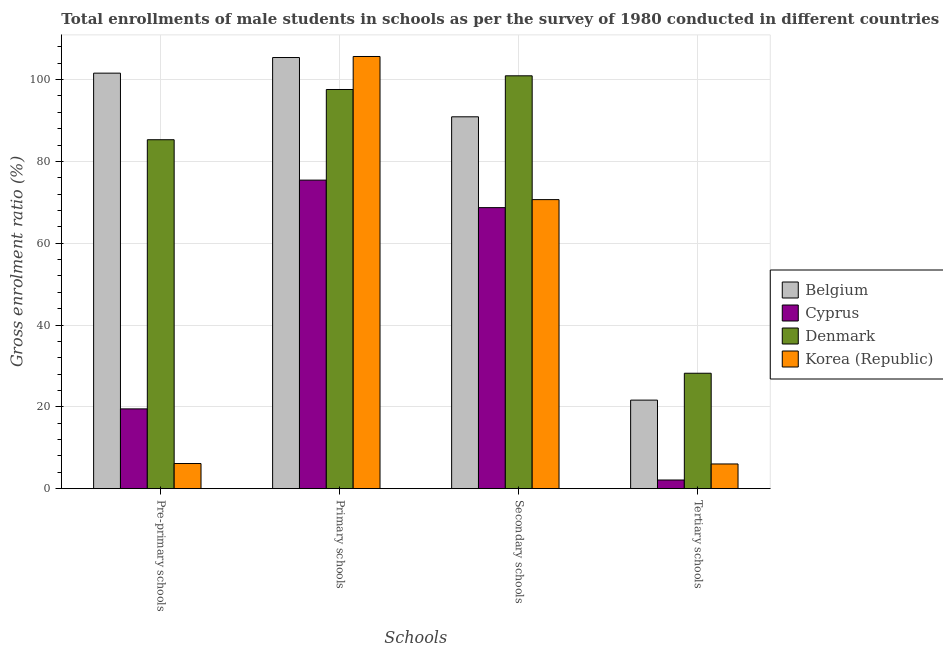Are the number of bars per tick equal to the number of legend labels?
Provide a short and direct response. Yes. How many bars are there on the 2nd tick from the left?
Ensure brevity in your answer.  4. What is the label of the 4th group of bars from the left?
Ensure brevity in your answer.  Tertiary schools. What is the gross enrolment ratio(male) in primary schools in Denmark?
Provide a short and direct response. 97.58. Across all countries, what is the maximum gross enrolment ratio(male) in tertiary schools?
Give a very brief answer. 28.22. Across all countries, what is the minimum gross enrolment ratio(male) in pre-primary schools?
Your response must be concise. 6.15. In which country was the gross enrolment ratio(male) in tertiary schools maximum?
Your response must be concise. Denmark. In which country was the gross enrolment ratio(male) in tertiary schools minimum?
Offer a terse response. Cyprus. What is the total gross enrolment ratio(male) in pre-primary schools in the graph?
Make the answer very short. 212.52. What is the difference between the gross enrolment ratio(male) in pre-primary schools in Cyprus and that in Belgium?
Give a very brief answer. -82.07. What is the difference between the gross enrolment ratio(male) in pre-primary schools in Korea (Republic) and the gross enrolment ratio(male) in secondary schools in Cyprus?
Provide a succinct answer. -62.55. What is the average gross enrolment ratio(male) in tertiary schools per country?
Offer a terse response. 14.51. What is the difference between the gross enrolment ratio(male) in secondary schools and gross enrolment ratio(male) in pre-primary schools in Belgium?
Ensure brevity in your answer.  -10.67. In how many countries, is the gross enrolment ratio(male) in secondary schools greater than 68 %?
Make the answer very short. 4. What is the ratio of the gross enrolment ratio(male) in pre-primary schools in Cyprus to that in Korea (Republic)?
Make the answer very short. 3.17. What is the difference between the highest and the second highest gross enrolment ratio(male) in primary schools?
Keep it short and to the point. 0.25. What is the difference between the highest and the lowest gross enrolment ratio(male) in secondary schools?
Your response must be concise. 32.22. In how many countries, is the gross enrolment ratio(male) in tertiary schools greater than the average gross enrolment ratio(male) in tertiary schools taken over all countries?
Your response must be concise. 2. Is the sum of the gross enrolment ratio(male) in secondary schools in Korea (Republic) and Cyprus greater than the maximum gross enrolment ratio(male) in pre-primary schools across all countries?
Ensure brevity in your answer.  Yes. What does the 3rd bar from the left in Primary schools represents?
Provide a succinct answer. Denmark. What does the 2nd bar from the right in Tertiary schools represents?
Ensure brevity in your answer.  Denmark. Is it the case that in every country, the sum of the gross enrolment ratio(male) in pre-primary schools and gross enrolment ratio(male) in primary schools is greater than the gross enrolment ratio(male) in secondary schools?
Provide a succinct answer. Yes. How many bars are there?
Provide a short and direct response. 16. Are all the bars in the graph horizontal?
Provide a succinct answer. No. How many countries are there in the graph?
Offer a very short reply. 4. What is the difference between two consecutive major ticks on the Y-axis?
Provide a succinct answer. 20. Are the values on the major ticks of Y-axis written in scientific E-notation?
Your response must be concise. No. How many legend labels are there?
Your answer should be compact. 4. How are the legend labels stacked?
Offer a terse response. Vertical. What is the title of the graph?
Give a very brief answer. Total enrollments of male students in schools as per the survey of 1980 conducted in different countries. Does "Senegal" appear as one of the legend labels in the graph?
Your answer should be very brief. No. What is the label or title of the X-axis?
Your response must be concise. Schools. What is the label or title of the Y-axis?
Your answer should be compact. Gross enrolment ratio (%). What is the Gross enrolment ratio (%) of Belgium in Pre-primary schools?
Your response must be concise. 101.57. What is the Gross enrolment ratio (%) of Cyprus in Pre-primary schools?
Give a very brief answer. 19.5. What is the Gross enrolment ratio (%) of Denmark in Pre-primary schools?
Your response must be concise. 85.29. What is the Gross enrolment ratio (%) in Korea (Republic) in Pre-primary schools?
Your answer should be compact. 6.15. What is the Gross enrolment ratio (%) of Belgium in Primary schools?
Your answer should be compact. 105.39. What is the Gross enrolment ratio (%) in Cyprus in Primary schools?
Provide a succinct answer. 75.42. What is the Gross enrolment ratio (%) in Denmark in Primary schools?
Your answer should be compact. 97.58. What is the Gross enrolment ratio (%) of Korea (Republic) in Primary schools?
Offer a very short reply. 105.64. What is the Gross enrolment ratio (%) in Belgium in Secondary schools?
Ensure brevity in your answer.  90.9. What is the Gross enrolment ratio (%) of Cyprus in Secondary schools?
Offer a terse response. 68.7. What is the Gross enrolment ratio (%) of Denmark in Secondary schools?
Ensure brevity in your answer.  100.92. What is the Gross enrolment ratio (%) of Korea (Republic) in Secondary schools?
Keep it short and to the point. 70.66. What is the Gross enrolment ratio (%) in Belgium in Tertiary schools?
Make the answer very short. 21.65. What is the Gross enrolment ratio (%) in Cyprus in Tertiary schools?
Offer a very short reply. 2.12. What is the Gross enrolment ratio (%) of Denmark in Tertiary schools?
Keep it short and to the point. 28.22. What is the Gross enrolment ratio (%) in Korea (Republic) in Tertiary schools?
Provide a succinct answer. 6.04. Across all Schools, what is the maximum Gross enrolment ratio (%) in Belgium?
Keep it short and to the point. 105.39. Across all Schools, what is the maximum Gross enrolment ratio (%) in Cyprus?
Give a very brief answer. 75.42. Across all Schools, what is the maximum Gross enrolment ratio (%) in Denmark?
Provide a succinct answer. 100.92. Across all Schools, what is the maximum Gross enrolment ratio (%) in Korea (Republic)?
Give a very brief answer. 105.64. Across all Schools, what is the minimum Gross enrolment ratio (%) of Belgium?
Ensure brevity in your answer.  21.65. Across all Schools, what is the minimum Gross enrolment ratio (%) of Cyprus?
Ensure brevity in your answer.  2.12. Across all Schools, what is the minimum Gross enrolment ratio (%) in Denmark?
Your answer should be very brief. 28.22. Across all Schools, what is the minimum Gross enrolment ratio (%) of Korea (Republic)?
Keep it short and to the point. 6.04. What is the total Gross enrolment ratio (%) of Belgium in the graph?
Offer a terse response. 319.5. What is the total Gross enrolment ratio (%) of Cyprus in the graph?
Ensure brevity in your answer.  165.74. What is the total Gross enrolment ratio (%) of Denmark in the graph?
Provide a succinct answer. 312. What is the total Gross enrolment ratio (%) in Korea (Republic) in the graph?
Make the answer very short. 188.49. What is the difference between the Gross enrolment ratio (%) of Belgium in Pre-primary schools and that in Primary schools?
Provide a short and direct response. -3.82. What is the difference between the Gross enrolment ratio (%) of Cyprus in Pre-primary schools and that in Primary schools?
Your response must be concise. -55.92. What is the difference between the Gross enrolment ratio (%) in Denmark in Pre-primary schools and that in Primary schools?
Ensure brevity in your answer.  -12.28. What is the difference between the Gross enrolment ratio (%) in Korea (Republic) in Pre-primary schools and that in Primary schools?
Provide a succinct answer. -99.49. What is the difference between the Gross enrolment ratio (%) in Belgium in Pre-primary schools and that in Secondary schools?
Offer a terse response. 10.67. What is the difference between the Gross enrolment ratio (%) of Cyprus in Pre-primary schools and that in Secondary schools?
Your answer should be compact. -49.2. What is the difference between the Gross enrolment ratio (%) in Denmark in Pre-primary schools and that in Secondary schools?
Your response must be concise. -15.62. What is the difference between the Gross enrolment ratio (%) in Korea (Republic) in Pre-primary schools and that in Secondary schools?
Provide a succinct answer. -64.51. What is the difference between the Gross enrolment ratio (%) in Belgium in Pre-primary schools and that in Tertiary schools?
Keep it short and to the point. 79.92. What is the difference between the Gross enrolment ratio (%) in Cyprus in Pre-primary schools and that in Tertiary schools?
Ensure brevity in your answer.  17.38. What is the difference between the Gross enrolment ratio (%) of Denmark in Pre-primary schools and that in Tertiary schools?
Ensure brevity in your answer.  57.08. What is the difference between the Gross enrolment ratio (%) in Korea (Republic) in Pre-primary schools and that in Tertiary schools?
Your answer should be very brief. 0.11. What is the difference between the Gross enrolment ratio (%) of Belgium in Primary schools and that in Secondary schools?
Provide a succinct answer. 14.49. What is the difference between the Gross enrolment ratio (%) of Cyprus in Primary schools and that in Secondary schools?
Give a very brief answer. 6.72. What is the difference between the Gross enrolment ratio (%) of Denmark in Primary schools and that in Secondary schools?
Provide a short and direct response. -3.34. What is the difference between the Gross enrolment ratio (%) in Korea (Republic) in Primary schools and that in Secondary schools?
Provide a succinct answer. 34.99. What is the difference between the Gross enrolment ratio (%) in Belgium in Primary schools and that in Tertiary schools?
Your answer should be very brief. 83.74. What is the difference between the Gross enrolment ratio (%) in Cyprus in Primary schools and that in Tertiary schools?
Ensure brevity in your answer.  73.3. What is the difference between the Gross enrolment ratio (%) in Denmark in Primary schools and that in Tertiary schools?
Provide a succinct answer. 69.36. What is the difference between the Gross enrolment ratio (%) of Korea (Republic) in Primary schools and that in Tertiary schools?
Offer a very short reply. 99.6. What is the difference between the Gross enrolment ratio (%) in Belgium in Secondary schools and that in Tertiary schools?
Keep it short and to the point. 69.25. What is the difference between the Gross enrolment ratio (%) in Cyprus in Secondary schools and that in Tertiary schools?
Keep it short and to the point. 66.58. What is the difference between the Gross enrolment ratio (%) of Denmark in Secondary schools and that in Tertiary schools?
Offer a terse response. 72.7. What is the difference between the Gross enrolment ratio (%) in Korea (Republic) in Secondary schools and that in Tertiary schools?
Your answer should be very brief. 64.62. What is the difference between the Gross enrolment ratio (%) in Belgium in Pre-primary schools and the Gross enrolment ratio (%) in Cyprus in Primary schools?
Your response must be concise. 26.15. What is the difference between the Gross enrolment ratio (%) in Belgium in Pre-primary schools and the Gross enrolment ratio (%) in Denmark in Primary schools?
Ensure brevity in your answer.  3.99. What is the difference between the Gross enrolment ratio (%) in Belgium in Pre-primary schools and the Gross enrolment ratio (%) in Korea (Republic) in Primary schools?
Keep it short and to the point. -4.07. What is the difference between the Gross enrolment ratio (%) of Cyprus in Pre-primary schools and the Gross enrolment ratio (%) of Denmark in Primary schools?
Offer a terse response. -78.07. What is the difference between the Gross enrolment ratio (%) in Cyprus in Pre-primary schools and the Gross enrolment ratio (%) in Korea (Republic) in Primary schools?
Offer a very short reply. -86.14. What is the difference between the Gross enrolment ratio (%) in Denmark in Pre-primary schools and the Gross enrolment ratio (%) in Korea (Republic) in Primary schools?
Your answer should be compact. -20.35. What is the difference between the Gross enrolment ratio (%) in Belgium in Pre-primary schools and the Gross enrolment ratio (%) in Cyprus in Secondary schools?
Give a very brief answer. 32.87. What is the difference between the Gross enrolment ratio (%) of Belgium in Pre-primary schools and the Gross enrolment ratio (%) of Denmark in Secondary schools?
Your answer should be very brief. 0.65. What is the difference between the Gross enrolment ratio (%) of Belgium in Pre-primary schools and the Gross enrolment ratio (%) of Korea (Republic) in Secondary schools?
Your answer should be compact. 30.91. What is the difference between the Gross enrolment ratio (%) of Cyprus in Pre-primary schools and the Gross enrolment ratio (%) of Denmark in Secondary schools?
Keep it short and to the point. -81.42. What is the difference between the Gross enrolment ratio (%) of Cyprus in Pre-primary schools and the Gross enrolment ratio (%) of Korea (Republic) in Secondary schools?
Make the answer very short. -51.15. What is the difference between the Gross enrolment ratio (%) of Denmark in Pre-primary schools and the Gross enrolment ratio (%) of Korea (Republic) in Secondary schools?
Provide a short and direct response. 14.64. What is the difference between the Gross enrolment ratio (%) in Belgium in Pre-primary schools and the Gross enrolment ratio (%) in Cyprus in Tertiary schools?
Your answer should be very brief. 99.45. What is the difference between the Gross enrolment ratio (%) in Belgium in Pre-primary schools and the Gross enrolment ratio (%) in Denmark in Tertiary schools?
Provide a succinct answer. 73.35. What is the difference between the Gross enrolment ratio (%) in Belgium in Pre-primary schools and the Gross enrolment ratio (%) in Korea (Republic) in Tertiary schools?
Give a very brief answer. 95.53. What is the difference between the Gross enrolment ratio (%) in Cyprus in Pre-primary schools and the Gross enrolment ratio (%) in Denmark in Tertiary schools?
Offer a very short reply. -8.71. What is the difference between the Gross enrolment ratio (%) in Cyprus in Pre-primary schools and the Gross enrolment ratio (%) in Korea (Republic) in Tertiary schools?
Provide a short and direct response. 13.46. What is the difference between the Gross enrolment ratio (%) of Denmark in Pre-primary schools and the Gross enrolment ratio (%) of Korea (Republic) in Tertiary schools?
Your answer should be very brief. 79.25. What is the difference between the Gross enrolment ratio (%) in Belgium in Primary schools and the Gross enrolment ratio (%) in Cyprus in Secondary schools?
Give a very brief answer. 36.69. What is the difference between the Gross enrolment ratio (%) of Belgium in Primary schools and the Gross enrolment ratio (%) of Denmark in Secondary schools?
Your response must be concise. 4.47. What is the difference between the Gross enrolment ratio (%) in Belgium in Primary schools and the Gross enrolment ratio (%) in Korea (Republic) in Secondary schools?
Make the answer very short. 34.73. What is the difference between the Gross enrolment ratio (%) of Cyprus in Primary schools and the Gross enrolment ratio (%) of Denmark in Secondary schools?
Make the answer very short. -25.5. What is the difference between the Gross enrolment ratio (%) of Cyprus in Primary schools and the Gross enrolment ratio (%) of Korea (Republic) in Secondary schools?
Make the answer very short. 4.76. What is the difference between the Gross enrolment ratio (%) of Denmark in Primary schools and the Gross enrolment ratio (%) of Korea (Republic) in Secondary schools?
Provide a short and direct response. 26.92. What is the difference between the Gross enrolment ratio (%) of Belgium in Primary schools and the Gross enrolment ratio (%) of Cyprus in Tertiary schools?
Your answer should be compact. 103.27. What is the difference between the Gross enrolment ratio (%) in Belgium in Primary schools and the Gross enrolment ratio (%) in Denmark in Tertiary schools?
Give a very brief answer. 77.18. What is the difference between the Gross enrolment ratio (%) of Belgium in Primary schools and the Gross enrolment ratio (%) of Korea (Republic) in Tertiary schools?
Your answer should be compact. 99.35. What is the difference between the Gross enrolment ratio (%) in Cyprus in Primary schools and the Gross enrolment ratio (%) in Denmark in Tertiary schools?
Provide a succinct answer. 47.21. What is the difference between the Gross enrolment ratio (%) in Cyprus in Primary schools and the Gross enrolment ratio (%) in Korea (Republic) in Tertiary schools?
Your answer should be compact. 69.38. What is the difference between the Gross enrolment ratio (%) in Denmark in Primary schools and the Gross enrolment ratio (%) in Korea (Republic) in Tertiary schools?
Make the answer very short. 91.53. What is the difference between the Gross enrolment ratio (%) in Belgium in Secondary schools and the Gross enrolment ratio (%) in Cyprus in Tertiary schools?
Provide a short and direct response. 88.78. What is the difference between the Gross enrolment ratio (%) of Belgium in Secondary schools and the Gross enrolment ratio (%) of Denmark in Tertiary schools?
Offer a terse response. 62.68. What is the difference between the Gross enrolment ratio (%) in Belgium in Secondary schools and the Gross enrolment ratio (%) in Korea (Republic) in Tertiary schools?
Provide a succinct answer. 84.86. What is the difference between the Gross enrolment ratio (%) of Cyprus in Secondary schools and the Gross enrolment ratio (%) of Denmark in Tertiary schools?
Make the answer very short. 40.48. What is the difference between the Gross enrolment ratio (%) of Cyprus in Secondary schools and the Gross enrolment ratio (%) of Korea (Republic) in Tertiary schools?
Ensure brevity in your answer.  62.66. What is the difference between the Gross enrolment ratio (%) of Denmark in Secondary schools and the Gross enrolment ratio (%) of Korea (Republic) in Tertiary schools?
Offer a terse response. 94.88. What is the average Gross enrolment ratio (%) in Belgium per Schools?
Your response must be concise. 79.88. What is the average Gross enrolment ratio (%) of Cyprus per Schools?
Give a very brief answer. 41.44. What is the average Gross enrolment ratio (%) in Denmark per Schools?
Keep it short and to the point. 78. What is the average Gross enrolment ratio (%) in Korea (Republic) per Schools?
Give a very brief answer. 47.12. What is the difference between the Gross enrolment ratio (%) of Belgium and Gross enrolment ratio (%) of Cyprus in Pre-primary schools?
Your answer should be compact. 82.07. What is the difference between the Gross enrolment ratio (%) of Belgium and Gross enrolment ratio (%) of Denmark in Pre-primary schools?
Provide a succinct answer. 16.27. What is the difference between the Gross enrolment ratio (%) in Belgium and Gross enrolment ratio (%) in Korea (Republic) in Pre-primary schools?
Make the answer very short. 95.42. What is the difference between the Gross enrolment ratio (%) in Cyprus and Gross enrolment ratio (%) in Denmark in Pre-primary schools?
Your answer should be very brief. -65.79. What is the difference between the Gross enrolment ratio (%) of Cyprus and Gross enrolment ratio (%) of Korea (Republic) in Pre-primary schools?
Provide a short and direct response. 13.36. What is the difference between the Gross enrolment ratio (%) in Denmark and Gross enrolment ratio (%) in Korea (Republic) in Pre-primary schools?
Ensure brevity in your answer.  79.15. What is the difference between the Gross enrolment ratio (%) in Belgium and Gross enrolment ratio (%) in Cyprus in Primary schools?
Offer a terse response. 29.97. What is the difference between the Gross enrolment ratio (%) in Belgium and Gross enrolment ratio (%) in Denmark in Primary schools?
Provide a short and direct response. 7.81. What is the difference between the Gross enrolment ratio (%) of Belgium and Gross enrolment ratio (%) of Korea (Republic) in Primary schools?
Make the answer very short. -0.25. What is the difference between the Gross enrolment ratio (%) in Cyprus and Gross enrolment ratio (%) in Denmark in Primary schools?
Provide a short and direct response. -22.15. What is the difference between the Gross enrolment ratio (%) of Cyprus and Gross enrolment ratio (%) of Korea (Republic) in Primary schools?
Your answer should be very brief. -30.22. What is the difference between the Gross enrolment ratio (%) of Denmark and Gross enrolment ratio (%) of Korea (Republic) in Primary schools?
Your answer should be very brief. -8.07. What is the difference between the Gross enrolment ratio (%) in Belgium and Gross enrolment ratio (%) in Cyprus in Secondary schools?
Your response must be concise. 22.2. What is the difference between the Gross enrolment ratio (%) of Belgium and Gross enrolment ratio (%) of Denmark in Secondary schools?
Offer a terse response. -10.02. What is the difference between the Gross enrolment ratio (%) in Belgium and Gross enrolment ratio (%) in Korea (Republic) in Secondary schools?
Make the answer very short. 20.24. What is the difference between the Gross enrolment ratio (%) in Cyprus and Gross enrolment ratio (%) in Denmark in Secondary schools?
Ensure brevity in your answer.  -32.22. What is the difference between the Gross enrolment ratio (%) in Cyprus and Gross enrolment ratio (%) in Korea (Republic) in Secondary schools?
Offer a very short reply. -1.96. What is the difference between the Gross enrolment ratio (%) of Denmark and Gross enrolment ratio (%) of Korea (Republic) in Secondary schools?
Ensure brevity in your answer.  30.26. What is the difference between the Gross enrolment ratio (%) in Belgium and Gross enrolment ratio (%) in Cyprus in Tertiary schools?
Keep it short and to the point. 19.53. What is the difference between the Gross enrolment ratio (%) of Belgium and Gross enrolment ratio (%) of Denmark in Tertiary schools?
Ensure brevity in your answer.  -6.57. What is the difference between the Gross enrolment ratio (%) of Belgium and Gross enrolment ratio (%) of Korea (Republic) in Tertiary schools?
Your response must be concise. 15.61. What is the difference between the Gross enrolment ratio (%) of Cyprus and Gross enrolment ratio (%) of Denmark in Tertiary schools?
Provide a succinct answer. -26.1. What is the difference between the Gross enrolment ratio (%) in Cyprus and Gross enrolment ratio (%) in Korea (Republic) in Tertiary schools?
Your answer should be very brief. -3.92. What is the difference between the Gross enrolment ratio (%) in Denmark and Gross enrolment ratio (%) in Korea (Republic) in Tertiary schools?
Ensure brevity in your answer.  22.17. What is the ratio of the Gross enrolment ratio (%) in Belgium in Pre-primary schools to that in Primary schools?
Your answer should be very brief. 0.96. What is the ratio of the Gross enrolment ratio (%) of Cyprus in Pre-primary schools to that in Primary schools?
Give a very brief answer. 0.26. What is the ratio of the Gross enrolment ratio (%) of Denmark in Pre-primary schools to that in Primary schools?
Offer a terse response. 0.87. What is the ratio of the Gross enrolment ratio (%) of Korea (Republic) in Pre-primary schools to that in Primary schools?
Make the answer very short. 0.06. What is the ratio of the Gross enrolment ratio (%) of Belgium in Pre-primary schools to that in Secondary schools?
Keep it short and to the point. 1.12. What is the ratio of the Gross enrolment ratio (%) of Cyprus in Pre-primary schools to that in Secondary schools?
Give a very brief answer. 0.28. What is the ratio of the Gross enrolment ratio (%) of Denmark in Pre-primary schools to that in Secondary schools?
Your response must be concise. 0.85. What is the ratio of the Gross enrolment ratio (%) in Korea (Republic) in Pre-primary schools to that in Secondary schools?
Provide a succinct answer. 0.09. What is the ratio of the Gross enrolment ratio (%) in Belgium in Pre-primary schools to that in Tertiary schools?
Make the answer very short. 4.69. What is the ratio of the Gross enrolment ratio (%) in Cyprus in Pre-primary schools to that in Tertiary schools?
Ensure brevity in your answer.  9.21. What is the ratio of the Gross enrolment ratio (%) of Denmark in Pre-primary schools to that in Tertiary schools?
Provide a short and direct response. 3.02. What is the ratio of the Gross enrolment ratio (%) of Korea (Republic) in Pre-primary schools to that in Tertiary schools?
Offer a very short reply. 1.02. What is the ratio of the Gross enrolment ratio (%) in Belgium in Primary schools to that in Secondary schools?
Give a very brief answer. 1.16. What is the ratio of the Gross enrolment ratio (%) of Cyprus in Primary schools to that in Secondary schools?
Provide a succinct answer. 1.1. What is the ratio of the Gross enrolment ratio (%) in Denmark in Primary schools to that in Secondary schools?
Offer a very short reply. 0.97. What is the ratio of the Gross enrolment ratio (%) of Korea (Republic) in Primary schools to that in Secondary schools?
Offer a very short reply. 1.5. What is the ratio of the Gross enrolment ratio (%) of Belgium in Primary schools to that in Tertiary schools?
Provide a short and direct response. 4.87. What is the ratio of the Gross enrolment ratio (%) of Cyprus in Primary schools to that in Tertiary schools?
Provide a succinct answer. 35.6. What is the ratio of the Gross enrolment ratio (%) of Denmark in Primary schools to that in Tertiary schools?
Offer a terse response. 3.46. What is the ratio of the Gross enrolment ratio (%) of Korea (Republic) in Primary schools to that in Tertiary schools?
Your answer should be very brief. 17.49. What is the ratio of the Gross enrolment ratio (%) of Belgium in Secondary schools to that in Tertiary schools?
Ensure brevity in your answer.  4.2. What is the ratio of the Gross enrolment ratio (%) of Cyprus in Secondary schools to that in Tertiary schools?
Ensure brevity in your answer.  32.43. What is the ratio of the Gross enrolment ratio (%) of Denmark in Secondary schools to that in Tertiary schools?
Your answer should be compact. 3.58. What is the ratio of the Gross enrolment ratio (%) in Korea (Republic) in Secondary schools to that in Tertiary schools?
Offer a terse response. 11.7. What is the difference between the highest and the second highest Gross enrolment ratio (%) in Belgium?
Offer a terse response. 3.82. What is the difference between the highest and the second highest Gross enrolment ratio (%) in Cyprus?
Keep it short and to the point. 6.72. What is the difference between the highest and the second highest Gross enrolment ratio (%) in Denmark?
Provide a short and direct response. 3.34. What is the difference between the highest and the second highest Gross enrolment ratio (%) in Korea (Republic)?
Your answer should be very brief. 34.99. What is the difference between the highest and the lowest Gross enrolment ratio (%) of Belgium?
Your answer should be very brief. 83.74. What is the difference between the highest and the lowest Gross enrolment ratio (%) in Cyprus?
Your response must be concise. 73.3. What is the difference between the highest and the lowest Gross enrolment ratio (%) in Denmark?
Make the answer very short. 72.7. What is the difference between the highest and the lowest Gross enrolment ratio (%) of Korea (Republic)?
Your response must be concise. 99.6. 